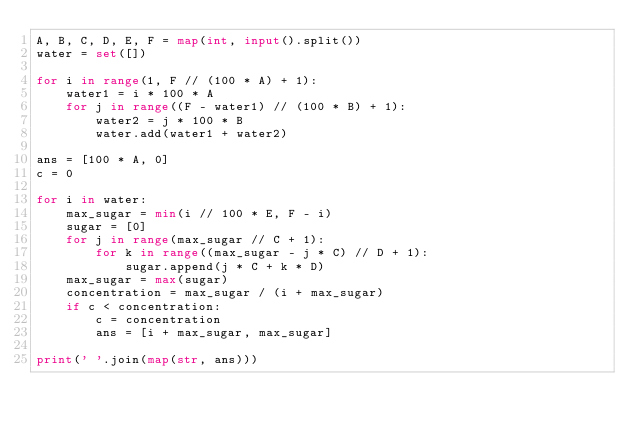<code> <loc_0><loc_0><loc_500><loc_500><_Python_>A, B, C, D, E, F = map(int, input().split())
water = set([])

for i in range(1, F // (100 * A) + 1):
    water1 = i * 100 * A
    for j in range((F - water1) // (100 * B) + 1):
        water2 = j * 100 * B
        water.add(water1 + water2)

ans = [100 * A, 0]
c = 0

for i in water:
    max_sugar = min(i // 100 * E, F - i)
    sugar = [0]
    for j in range(max_sugar // C + 1):
        for k in range((max_sugar - j * C) // D + 1):
            sugar.append(j * C + k * D)
    max_sugar = max(sugar)
    concentration = max_sugar / (i + max_sugar)
    if c < concentration:
        c = concentration
        ans = [i + max_sugar, max_sugar]

print(' '.join(map(str, ans)))</code> 